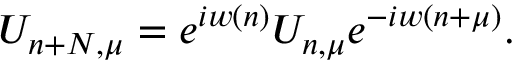<formula> <loc_0><loc_0><loc_500><loc_500>U _ { n + N , \mu } = e ^ { i w ( n ) } U _ { n , \mu } e ^ { - i w ( n + \mu ) } .</formula> 